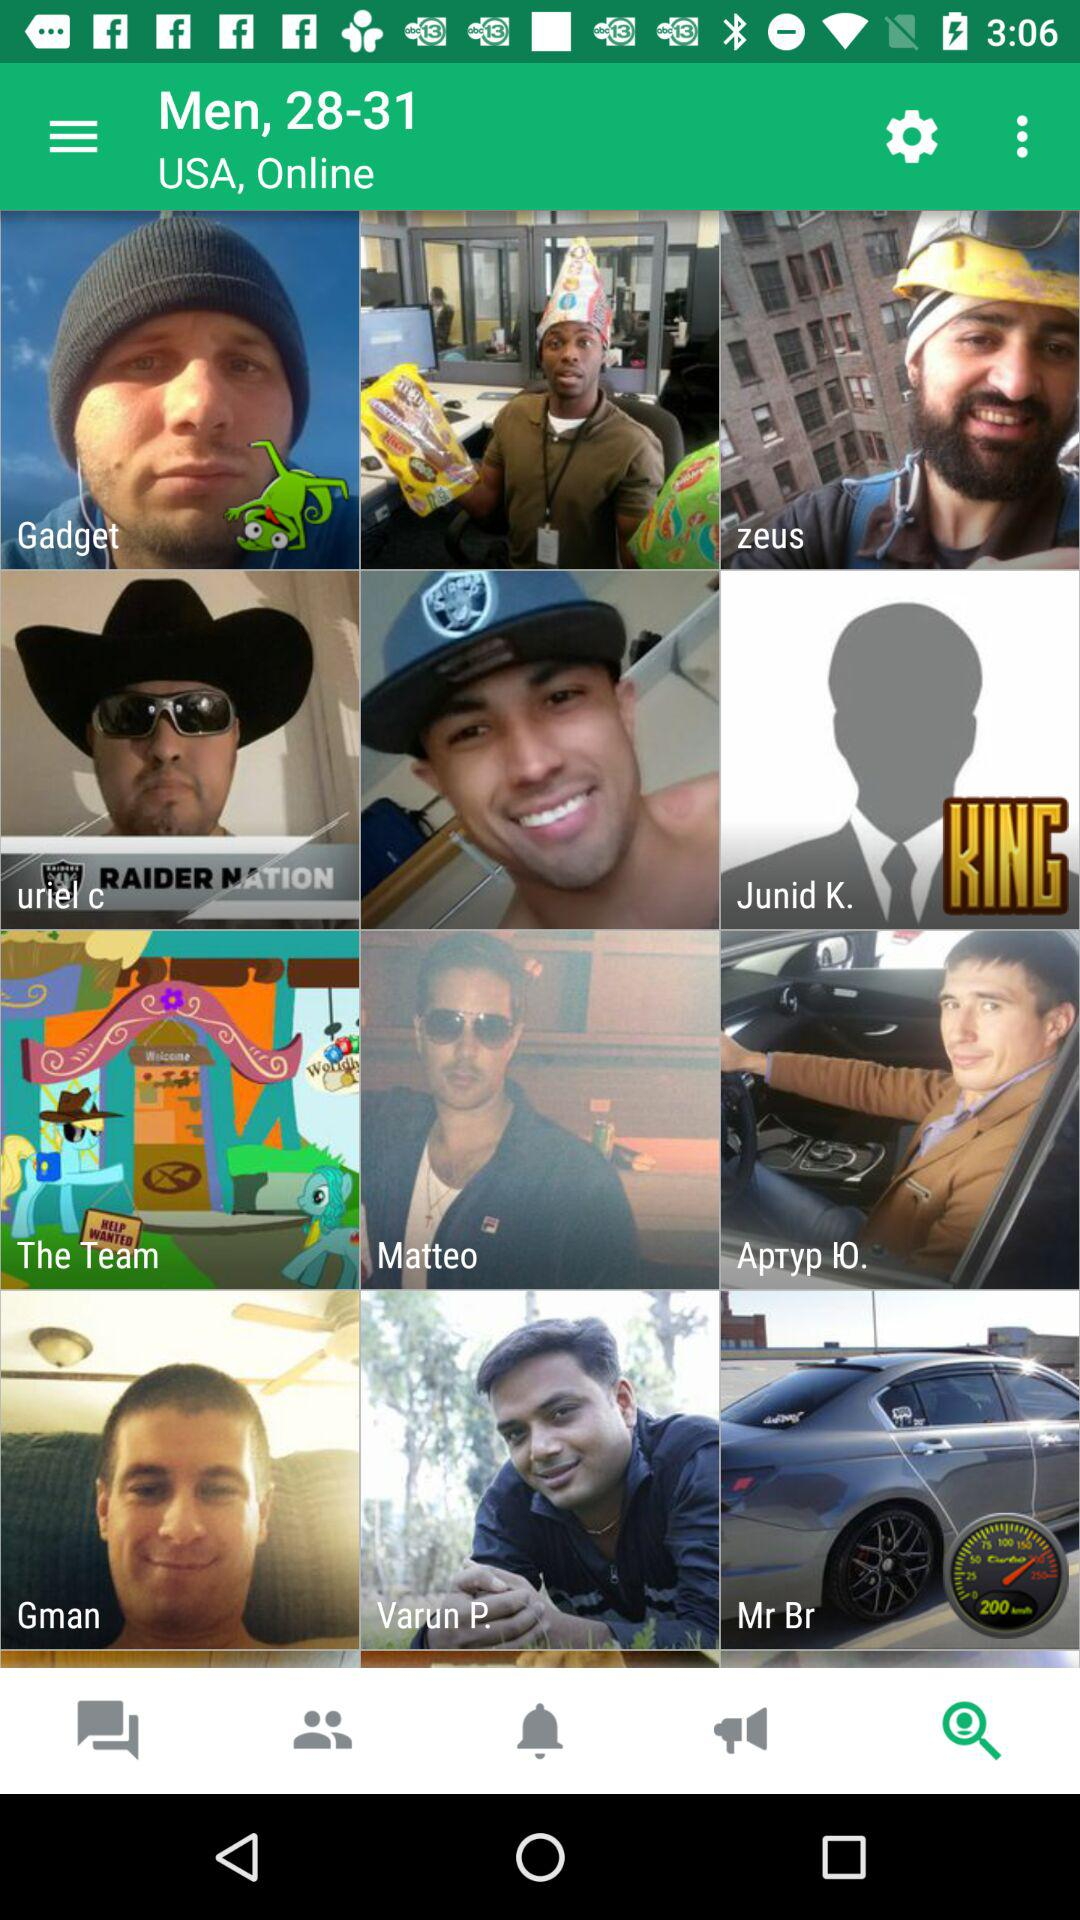What is the location? The location is the USA. 